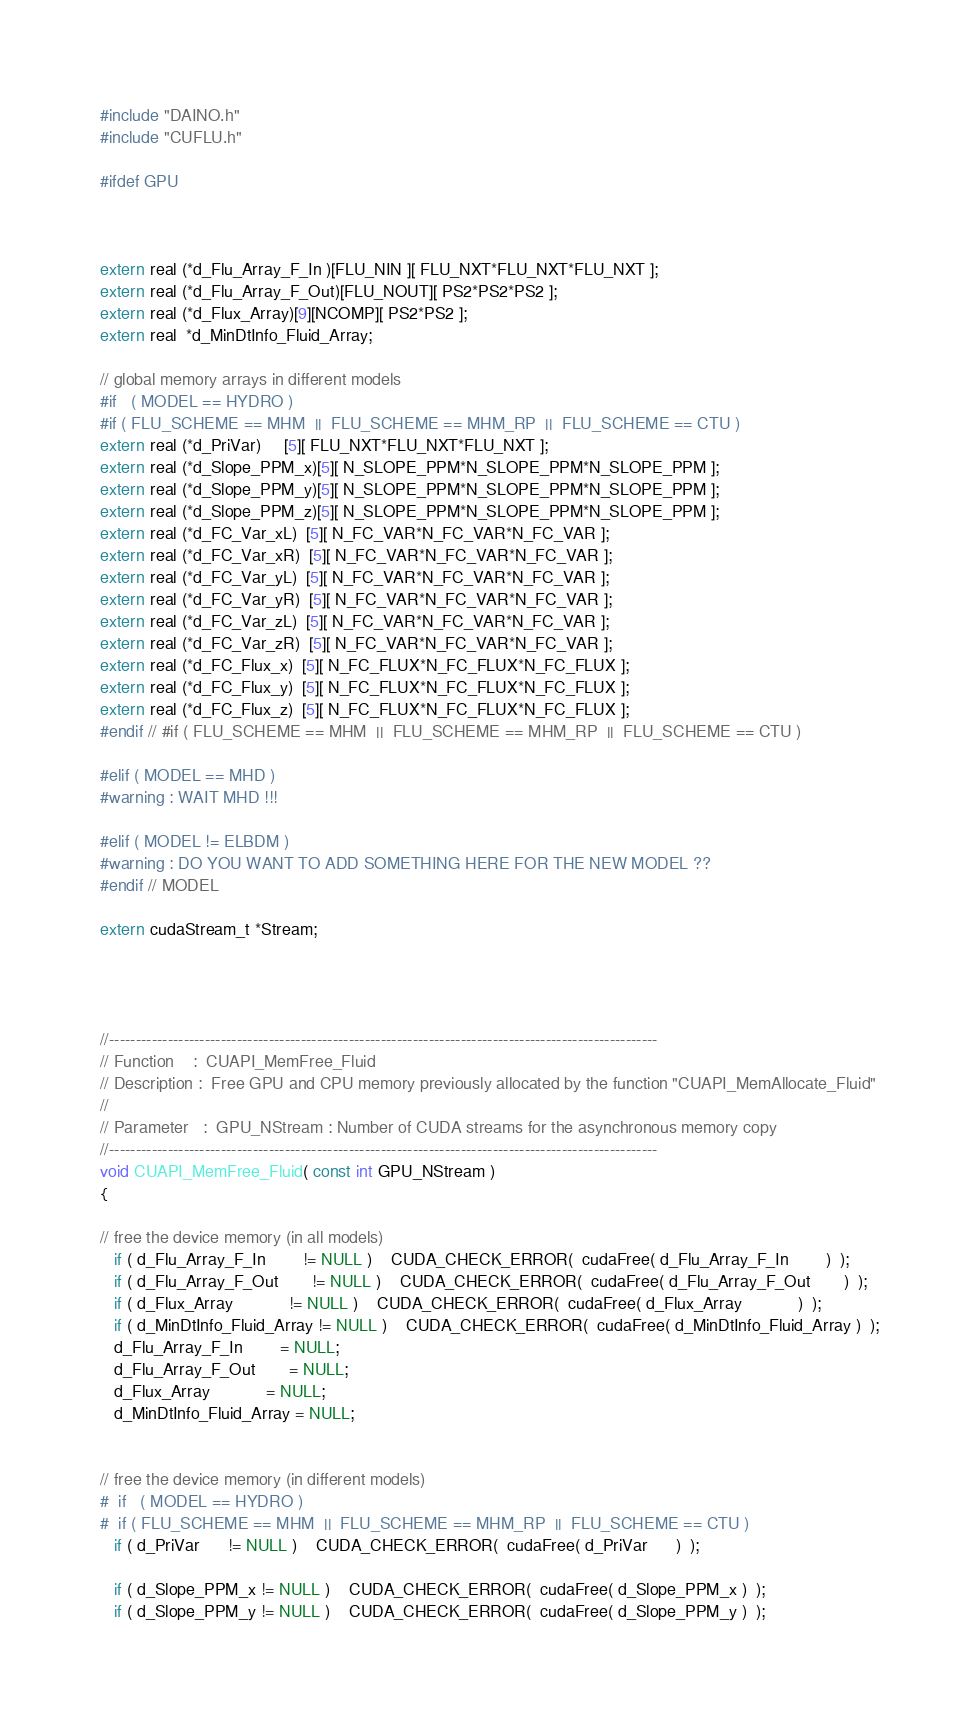Convert code to text. <code><loc_0><loc_0><loc_500><loc_500><_Cuda_>
#include "DAINO.h"
#include "CUFLU.h"

#ifdef GPU



extern real (*d_Flu_Array_F_In )[FLU_NIN ][ FLU_NXT*FLU_NXT*FLU_NXT ];
extern real (*d_Flu_Array_F_Out)[FLU_NOUT][ PS2*PS2*PS2 ];
extern real (*d_Flux_Array)[9][NCOMP][ PS2*PS2 ];
extern real  *d_MinDtInfo_Fluid_Array;

// global memory arrays in different models
#if   ( MODEL == HYDRO )
#if ( FLU_SCHEME == MHM  ||  FLU_SCHEME == MHM_RP  ||  FLU_SCHEME == CTU )
extern real (*d_PriVar)     [5][ FLU_NXT*FLU_NXT*FLU_NXT ];
extern real (*d_Slope_PPM_x)[5][ N_SLOPE_PPM*N_SLOPE_PPM*N_SLOPE_PPM ];
extern real (*d_Slope_PPM_y)[5][ N_SLOPE_PPM*N_SLOPE_PPM*N_SLOPE_PPM ];
extern real (*d_Slope_PPM_z)[5][ N_SLOPE_PPM*N_SLOPE_PPM*N_SLOPE_PPM ];
extern real (*d_FC_Var_xL)  [5][ N_FC_VAR*N_FC_VAR*N_FC_VAR ];
extern real (*d_FC_Var_xR)  [5][ N_FC_VAR*N_FC_VAR*N_FC_VAR ];
extern real (*d_FC_Var_yL)  [5][ N_FC_VAR*N_FC_VAR*N_FC_VAR ];
extern real (*d_FC_Var_yR)  [5][ N_FC_VAR*N_FC_VAR*N_FC_VAR ];
extern real (*d_FC_Var_zL)  [5][ N_FC_VAR*N_FC_VAR*N_FC_VAR ];
extern real (*d_FC_Var_zR)  [5][ N_FC_VAR*N_FC_VAR*N_FC_VAR ];
extern real (*d_FC_Flux_x)  [5][ N_FC_FLUX*N_FC_FLUX*N_FC_FLUX ];
extern real (*d_FC_Flux_y)  [5][ N_FC_FLUX*N_FC_FLUX*N_FC_FLUX ];
extern real (*d_FC_Flux_z)  [5][ N_FC_FLUX*N_FC_FLUX*N_FC_FLUX ];
#endif // #if ( FLU_SCHEME == MHM  ||  FLU_SCHEME == MHM_RP  ||  FLU_SCHEME == CTU )

#elif ( MODEL == MHD )
#warning : WAIT MHD !!!

#elif ( MODEL != ELBDM )
#warning : DO YOU WANT TO ADD SOMETHING HERE FOR THE NEW MODEL ??
#endif // MODEL

extern cudaStream_t *Stream;




//-------------------------------------------------------------------------------------------------------
// Function    :  CUAPI_MemFree_Fluid
// Description :  Free GPU and CPU memory previously allocated by the function "CUAPI_MemAllocate_Fluid"
//
// Parameter   :  GPU_NStream : Number of CUDA streams for the asynchronous memory copy
//-------------------------------------------------------------------------------------------------------
void CUAPI_MemFree_Fluid( const int GPU_NStream )
{

// free the device memory (in all models)
   if ( d_Flu_Array_F_In        != NULL )    CUDA_CHECK_ERROR(  cudaFree( d_Flu_Array_F_In        )  );
   if ( d_Flu_Array_F_Out       != NULL )    CUDA_CHECK_ERROR(  cudaFree( d_Flu_Array_F_Out       )  );
   if ( d_Flux_Array            != NULL )    CUDA_CHECK_ERROR(  cudaFree( d_Flux_Array            )  );
   if ( d_MinDtInfo_Fluid_Array != NULL )    CUDA_CHECK_ERROR(  cudaFree( d_MinDtInfo_Fluid_Array )  );
   d_Flu_Array_F_In        = NULL;
   d_Flu_Array_F_Out       = NULL;
   d_Flux_Array            = NULL;
   d_MinDtInfo_Fluid_Array = NULL;


// free the device memory (in different models)
#  if   ( MODEL == HYDRO )
#  if ( FLU_SCHEME == MHM  ||  FLU_SCHEME == MHM_RP  ||  FLU_SCHEME == CTU )
   if ( d_PriVar      != NULL )    CUDA_CHECK_ERROR(  cudaFree( d_PriVar      )  );

   if ( d_Slope_PPM_x != NULL )    CUDA_CHECK_ERROR(  cudaFree( d_Slope_PPM_x )  );
   if ( d_Slope_PPM_y != NULL )    CUDA_CHECK_ERROR(  cudaFree( d_Slope_PPM_y )  );</code> 